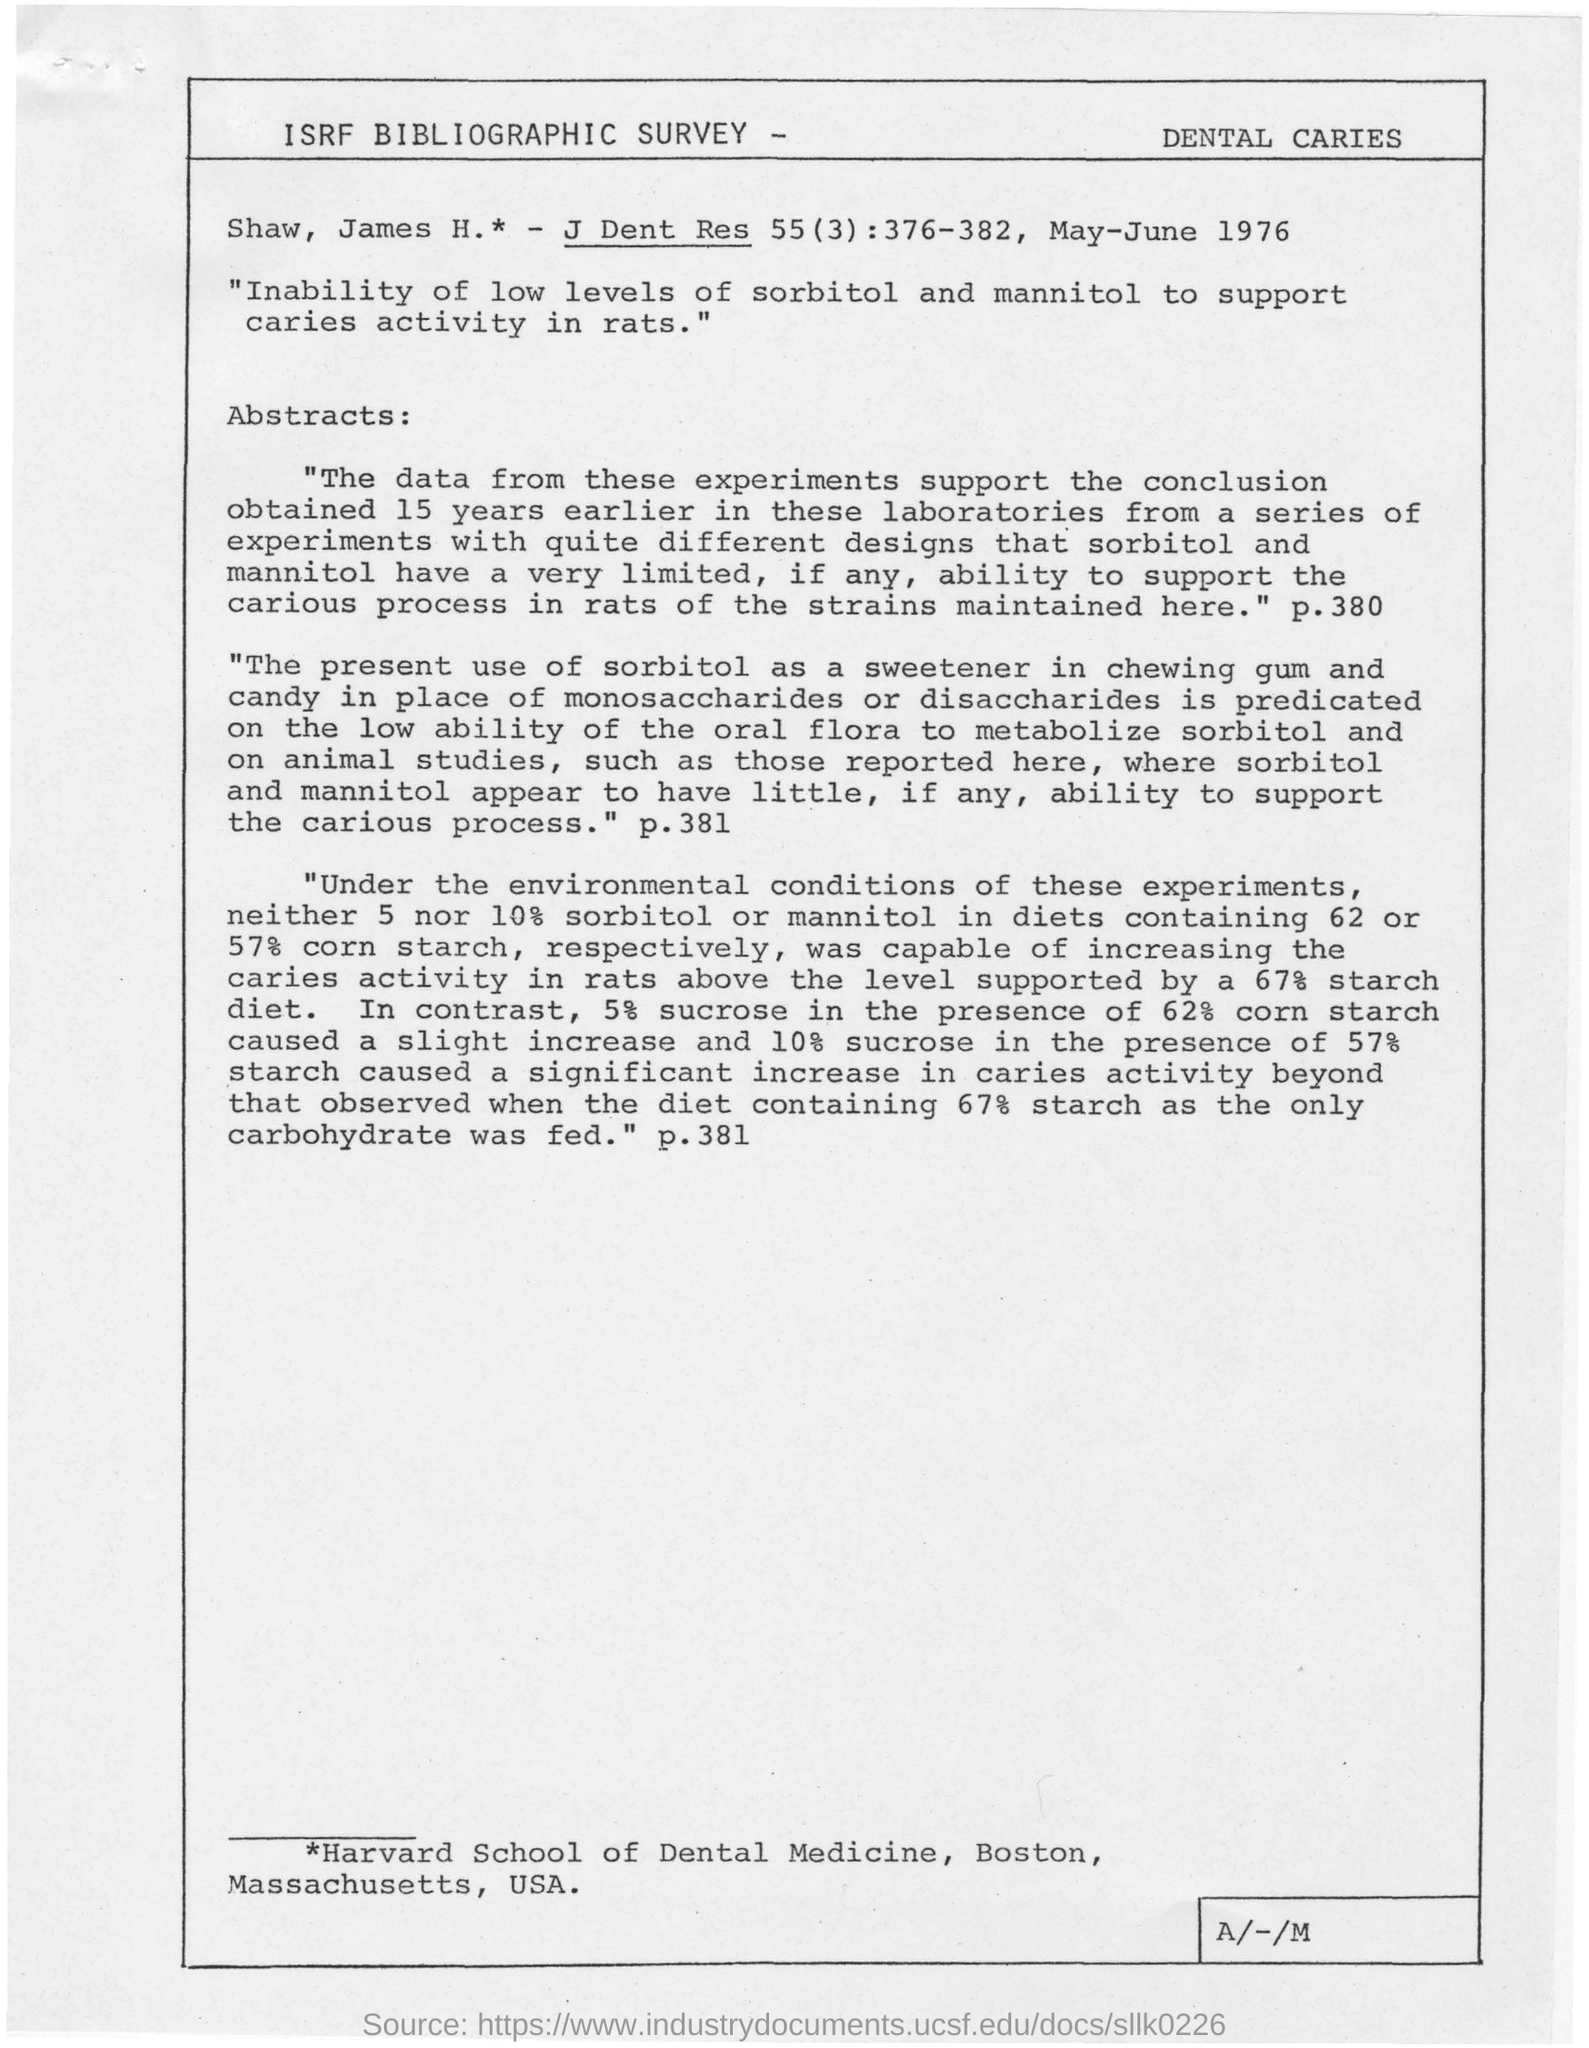Which animal is used to check the inability of low levels of sorbitol and mannitol?
Give a very brief answer. Rats. Which institution is mentioned in the footer?
Offer a terse response. Harvard School of Dental Medicine, Boston, Massachusetts, USA. 